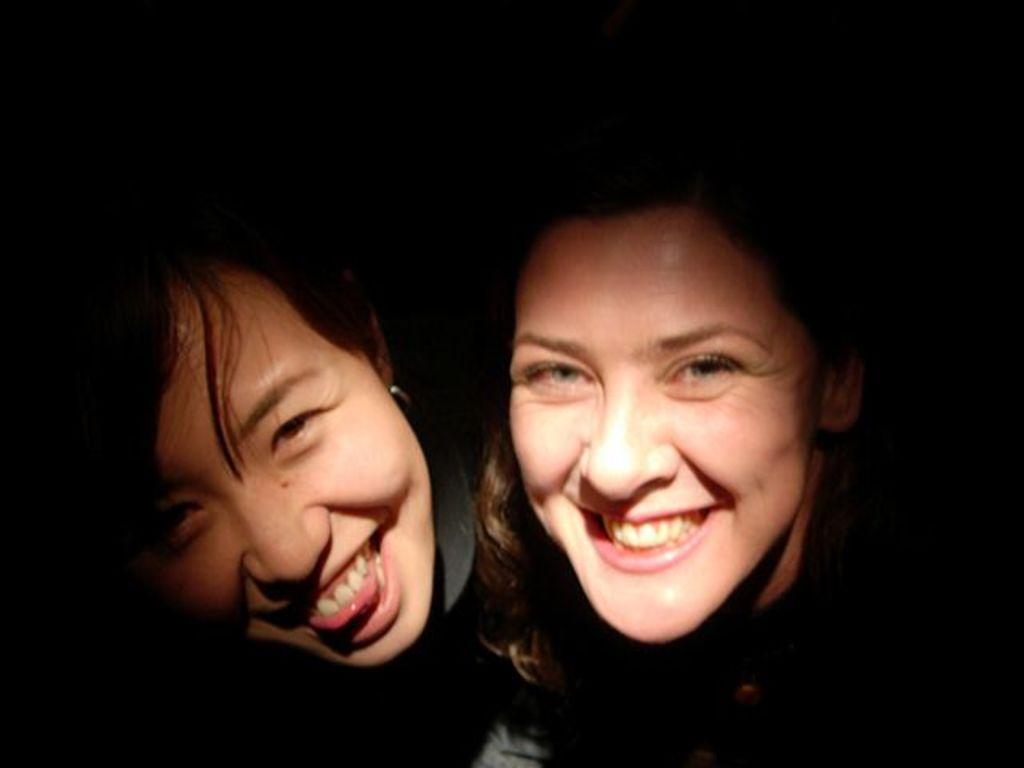How many people are in the image? There are two people in the image. What is the facial expression of the people in the image? The people are smiling. What color is the background of the image? The background of the image is black in color. How many apples are on the table in the image? There is no table or apples present in the image. What type of coat is the person wearing in the image? There is no coat visible in the image, as the people are not wearing any outerwear. 